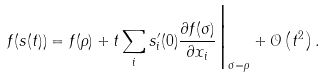<formula> <loc_0><loc_0><loc_500><loc_500>f ( s ( t ) ) = f ( \rho ) + t \sum _ { i } s ^ { \prime } _ { i } ( 0 ) \frac { \partial f ( \sigma ) } { \partial x _ { i } } \Big | _ { \sigma = \rho } + \mathcal { O } \left ( t ^ { 2 } \right ) .</formula> 